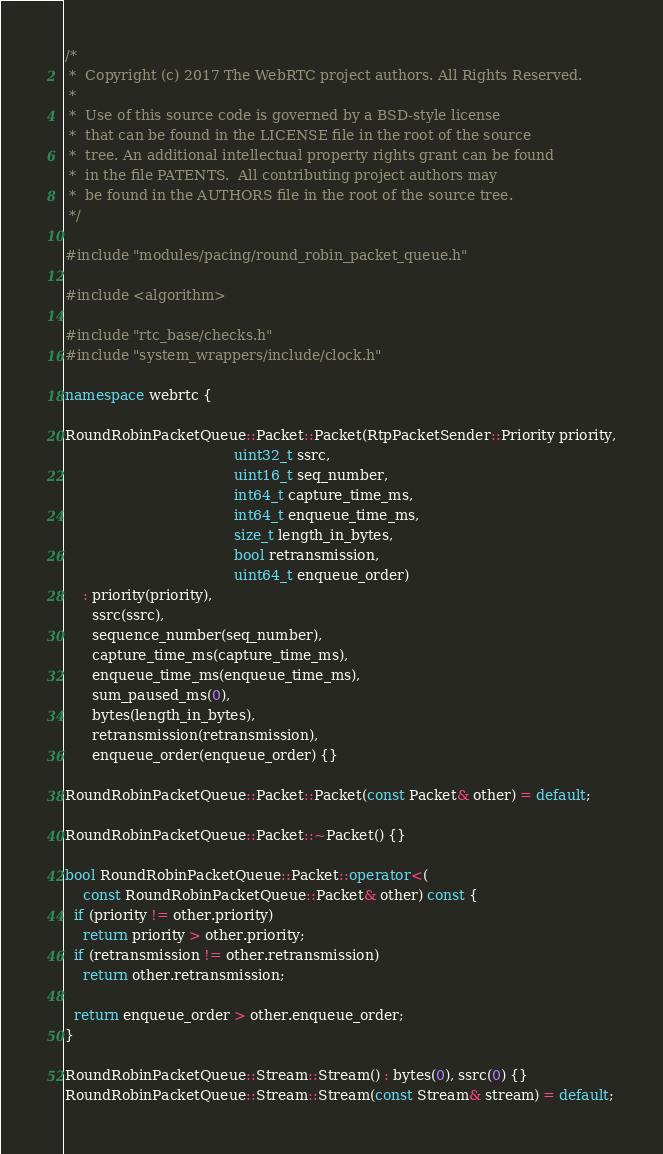Convert code to text. <code><loc_0><loc_0><loc_500><loc_500><_C++_>/*
 *  Copyright (c) 2017 The WebRTC project authors. All Rights Reserved.
 *
 *  Use of this source code is governed by a BSD-style license
 *  that can be found in the LICENSE file in the root of the source
 *  tree. An additional intellectual property rights grant can be found
 *  in the file PATENTS.  All contributing project authors may
 *  be found in the AUTHORS file in the root of the source tree.
 */

#include "modules/pacing/round_robin_packet_queue.h"

#include <algorithm>

#include "rtc_base/checks.h"
#include "system_wrappers/include/clock.h"

namespace webrtc {

RoundRobinPacketQueue::Packet::Packet(RtpPacketSender::Priority priority,
                                      uint32_t ssrc,
                                      uint16_t seq_number,
                                      int64_t capture_time_ms,
                                      int64_t enqueue_time_ms,
                                      size_t length_in_bytes,
                                      bool retransmission,
                                      uint64_t enqueue_order)
    : priority(priority),
      ssrc(ssrc),
      sequence_number(seq_number),
      capture_time_ms(capture_time_ms),
      enqueue_time_ms(enqueue_time_ms),
      sum_paused_ms(0),
      bytes(length_in_bytes),
      retransmission(retransmission),
      enqueue_order(enqueue_order) {}

RoundRobinPacketQueue::Packet::Packet(const Packet& other) = default;

RoundRobinPacketQueue::Packet::~Packet() {}

bool RoundRobinPacketQueue::Packet::operator<(
    const RoundRobinPacketQueue::Packet& other) const {
  if (priority != other.priority)
    return priority > other.priority;
  if (retransmission != other.retransmission)
    return other.retransmission;

  return enqueue_order > other.enqueue_order;
}

RoundRobinPacketQueue::Stream::Stream() : bytes(0), ssrc(0) {}
RoundRobinPacketQueue::Stream::Stream(const Stream& stream) = default;</code> 